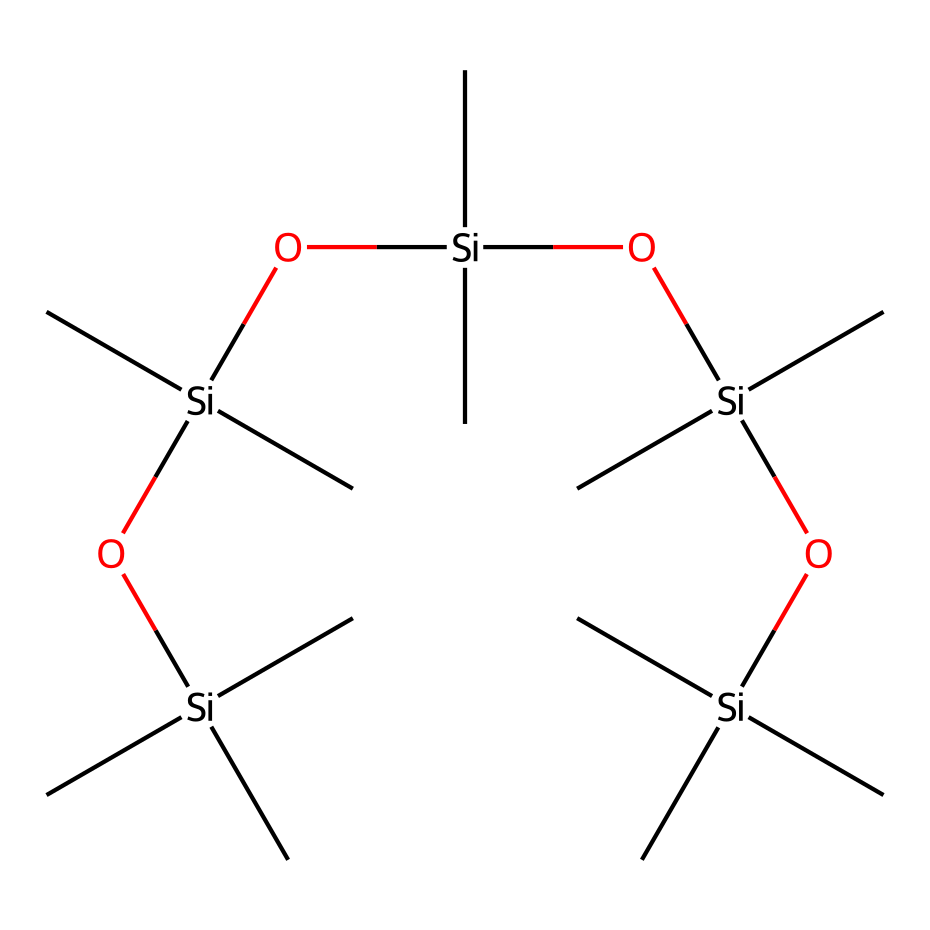what is the total number of silicon atoms in the structure? By analyzing the SMILES representation, we can count the number of instances of the silicon element 'Si'. The structure contains five occurrences of 'Si'.
Answer: five how many oxygen atoms are present in the chemical? Similarly, we look for the oxygen element 'O' in the SMILES string. There are four instances of 'O' in the chemical structure.
Answer: four what type of chemical compound is represented by this structure? The chemical contains silicon and oxygen atoms, indicating that it is a siloxane compound, specifically a silane with siloxane linkages.
Answer: siloxane how many carbon branches are there per silicon atom in this structure? The structure shows that each silicon atom is connected to three carbon atoms based on the '(C)' groups which are attached to each 'Si'. Therefore, for each silicon atom, there are three carbon branches.
Answer: three what is the primary function of this siloxane-based compound? The primary function of this siloxane compound is to provide water repellency, as it is specifically designed for fabric protection against water.
Answer: water repellent does the structure indicate that it is hydrophobic in nature? The presence of siloxane linkages and the arrangement of carbon and silicon suggest that the compound is hydrophobic, as siloxanes generally exhibit water-repellent properties.
Answer: yes how many siloxane linkages are present in the molecule? The molecule contains four instances of the 'O[Si]' sequence which indicates that there are four siloxane linkages present in the compound.
Answer: four 